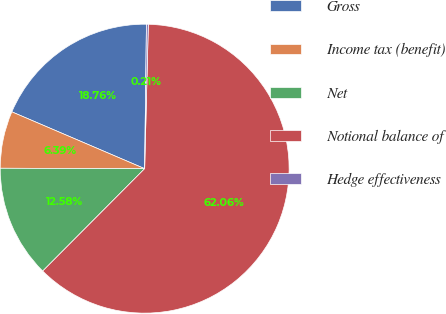Convert chart to OTSL. <chart><loc_0><loc_0><loc_500><loc_500><pie_chart><fcel>Gross<fcel>Income tax (benefit)<fcel>Net<fcel>Notional balance of<fcel>Hedge effectiveness<nl><fcel>18.76%<fcel>6.39%<fcel>12.58%<fcel>62.06%<fcel>0.21%<nl></chart> 